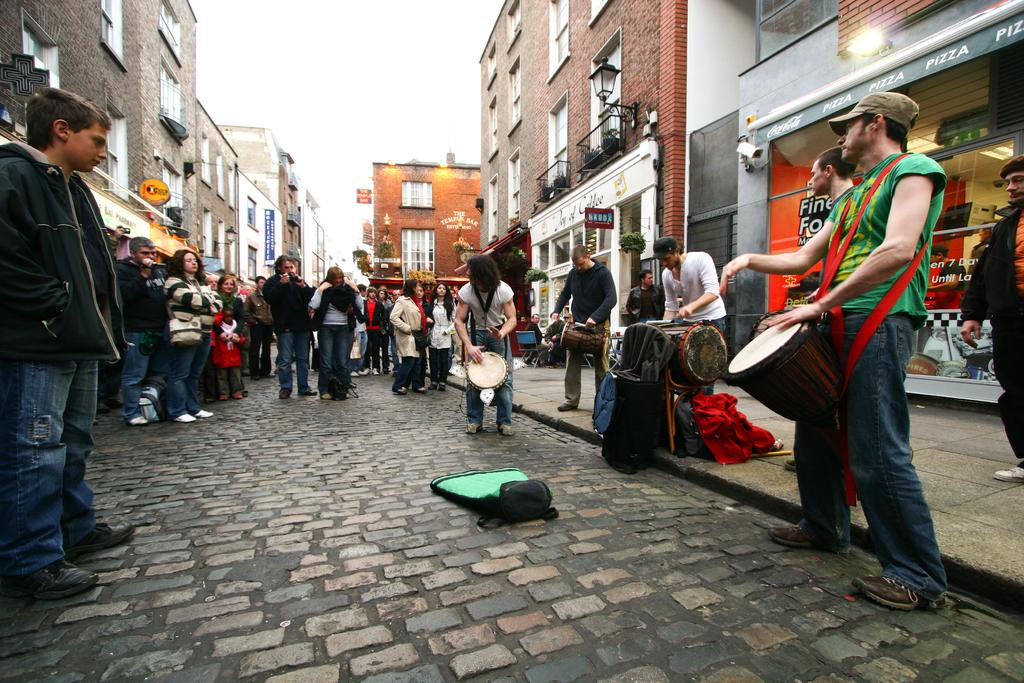What are the people in the image doing? There are people standing on the road and playing drums. What can be seen in the background of the image? There are buildings in the background. What is the condition of the sky in the image? The sky is clear in the image. How many pizzas are being served on the road in the image? There are no pizzas present in the image. What type of current is flowing through the drumsticks in the image? There is no current flowing through the drumsticks in the image, as they are being played manually. 